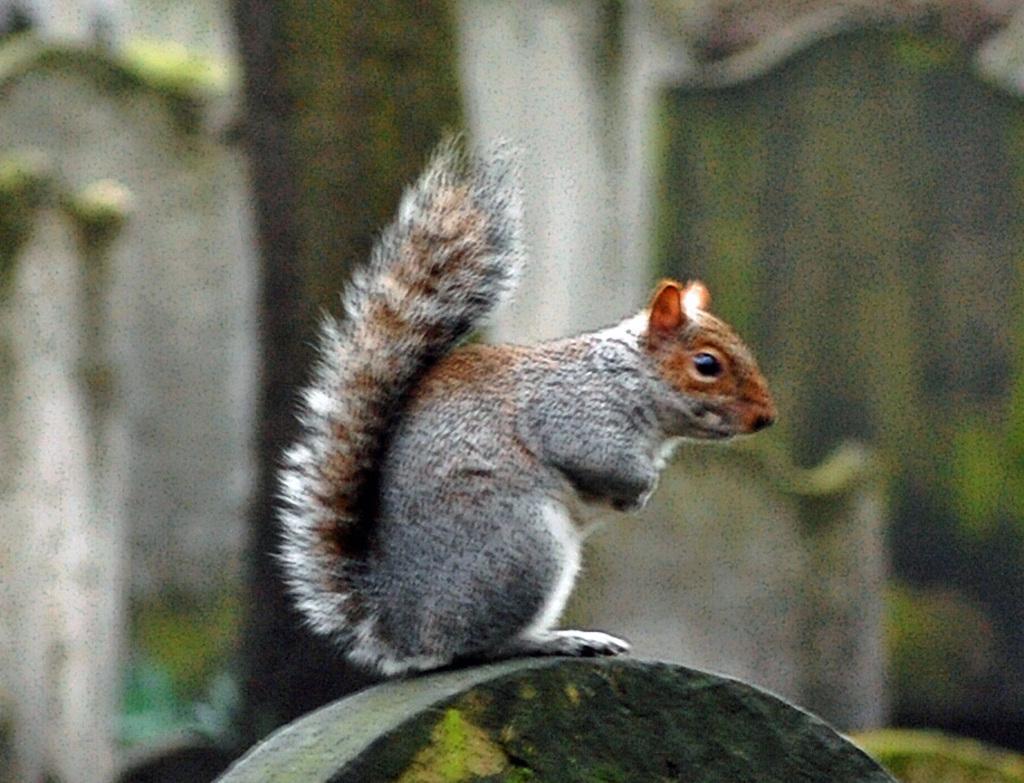Could you give a brief overview of what you see in this image? In this image I can see a green colour thing and on it I can see a squirrel. I can see colour of this squirrel is white and brown. 